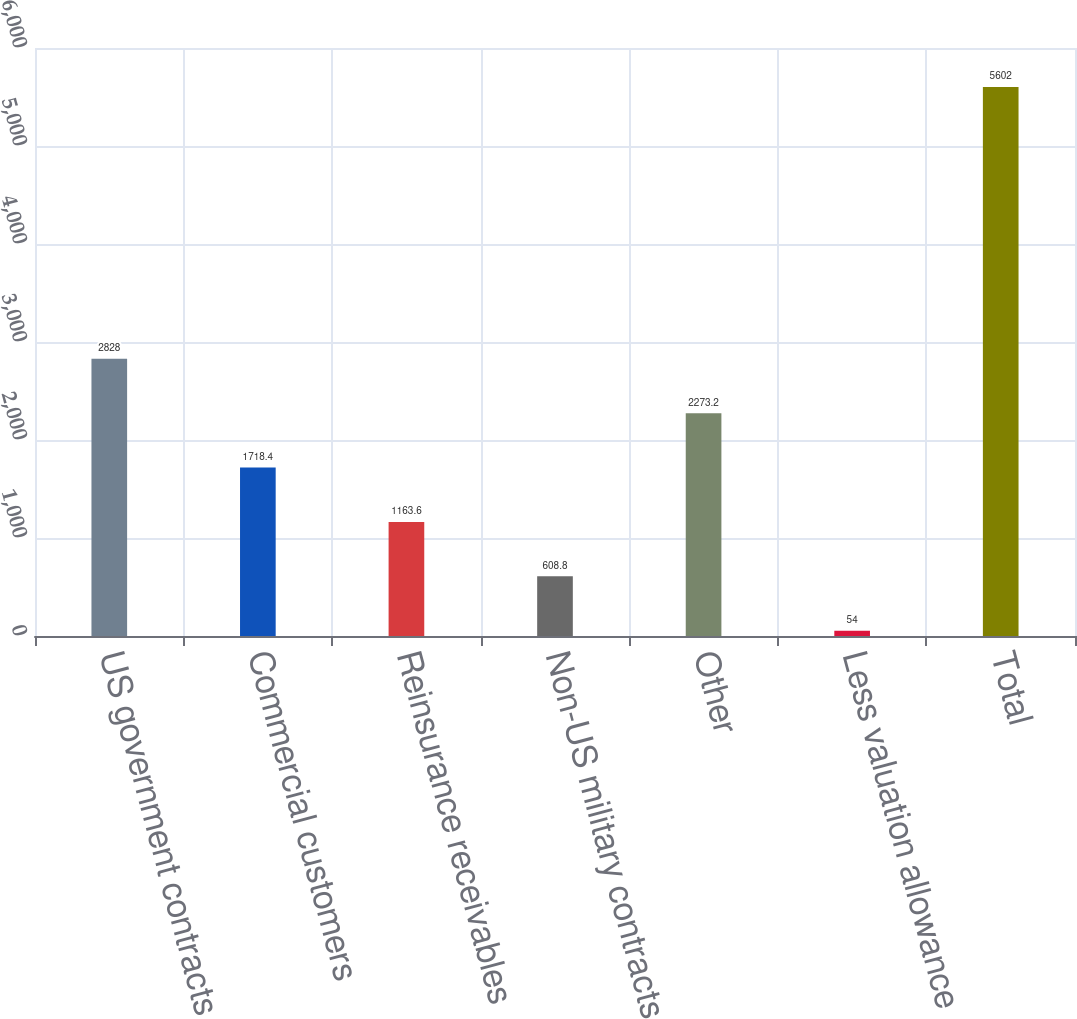<chart> <loc_0><loc_0><loc_500><loc_500><bar_chart><fcel>US government contracts<fcel>Commercial customers<fcel>Reinsurance receivables<fcel>Non-US military contracts<fcel>Other<fcel>Less valuation allowance<fcel>Total<nl><fcel>2828<fcel>1718.4<fcel>1163.6<fcel>608.8<fcel>2273.2<fcel>54<fcel>5602<nl></chart> 